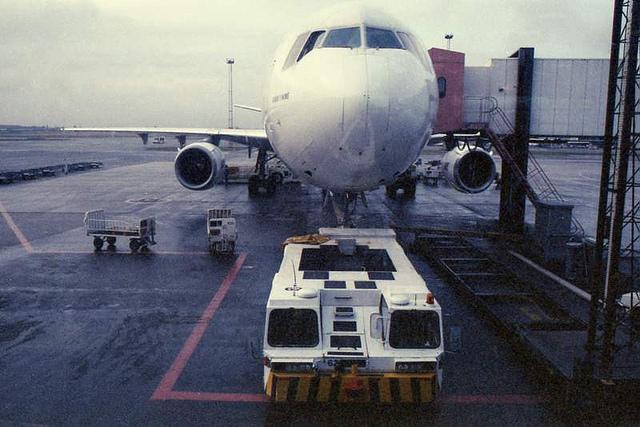How many of the cats look comfortable?
Give a very brief answer. 0. 